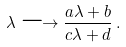Convert formula to latex. <formula><loc_0><loc_0><loc_500><loc_500>\lambda \longrightarrow \frac { a \lambda + b } { c \lambda + d } \, .</formula> 